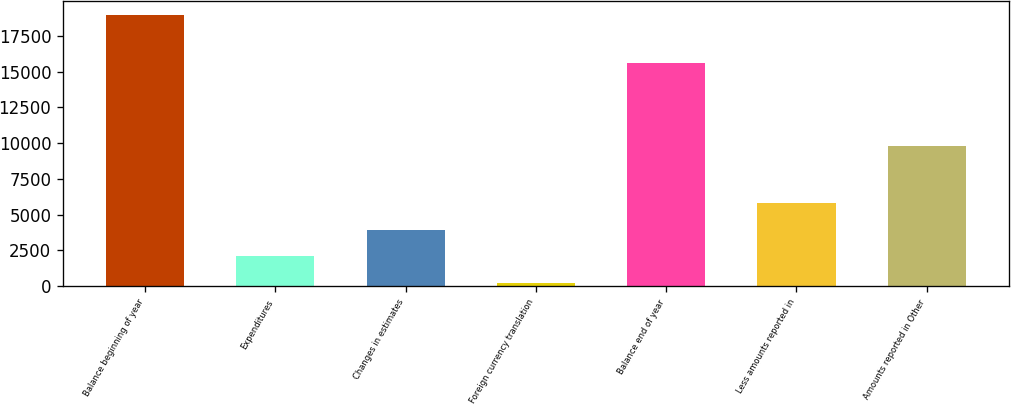Convert chart to OTSL. <chart><loc_0><loc_0><loc_500><loc_500><bar_chart><fcel>Balance beginning of year<fcel>Expenditures<fcel>Changes in estimates<fcel>Foreign currency translation<fcel>Balance end of year<fcel>Less amounts reported in<fcel>Amounts reported in Other<nl><fcel>18970<fcel>2088.7<fcel>3964.4<fcel>213<fcel>15567<fcel>5840.1<fcel>9792<nl></chart> 